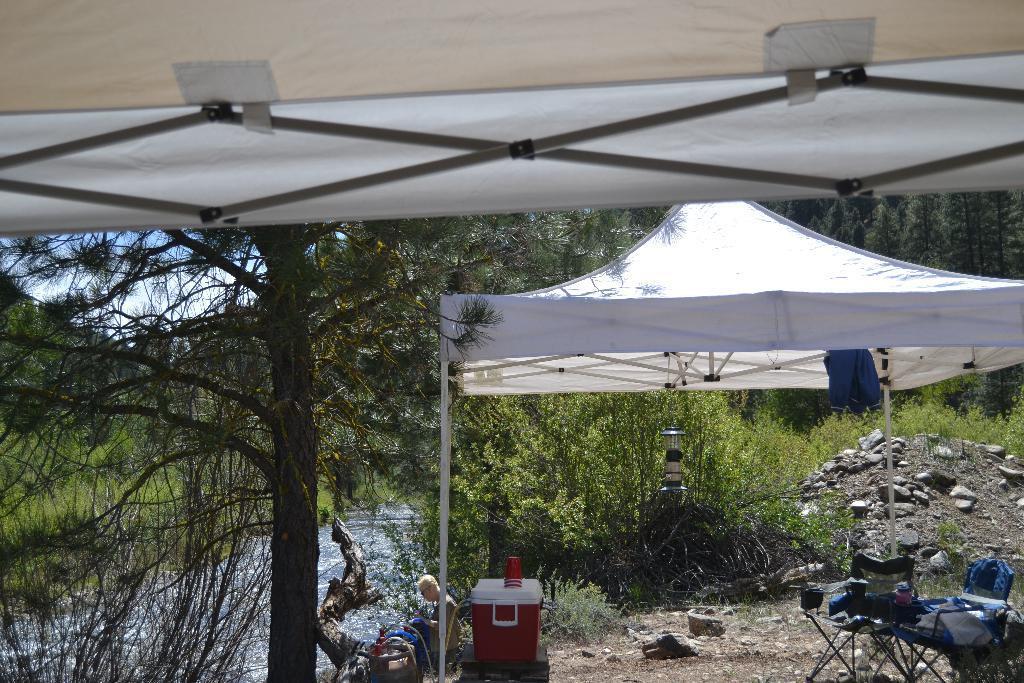Describe this image in one or two sentences. In the image we can see a person wearing clothes and goggles. This is a container, glass, table, cloths, stones, water, tree, sky and a tent. 